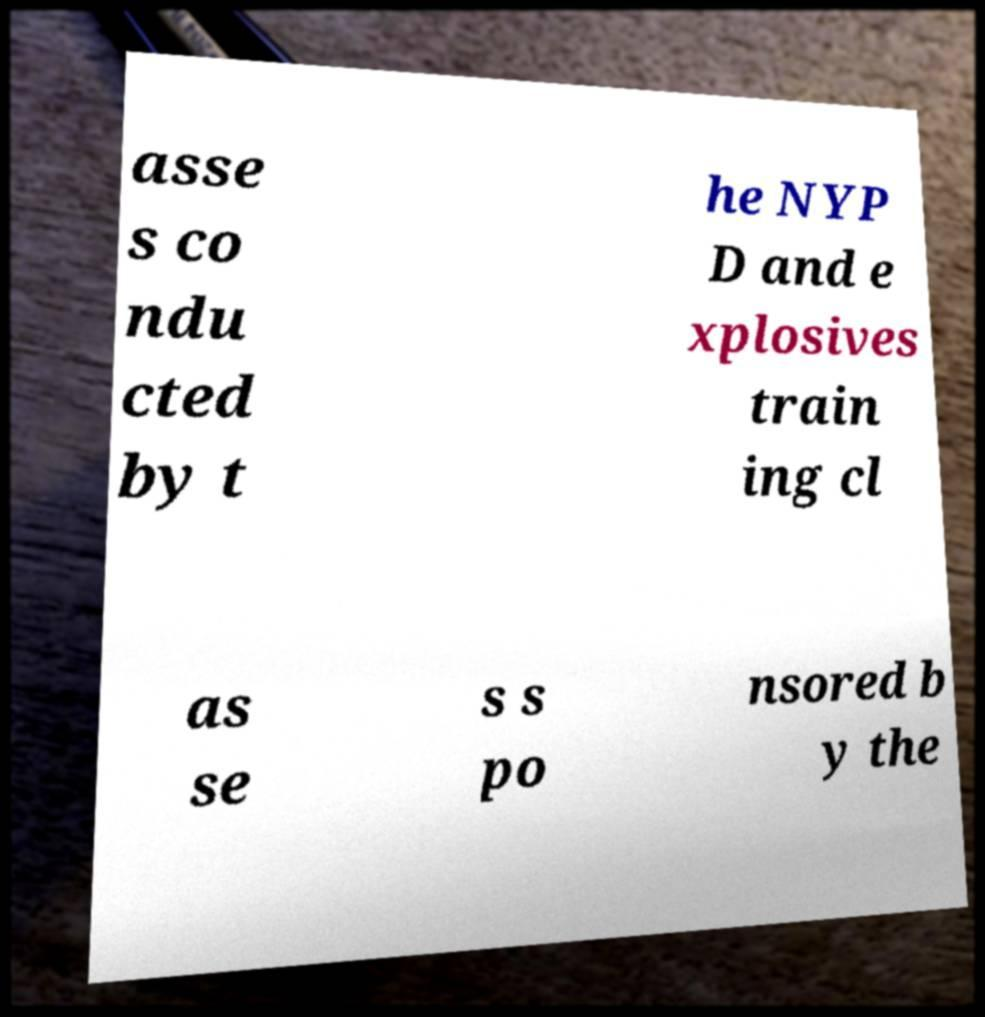There's text embedded in this image that I need extracted. Can you transcribe it verbatim? asse s co ndu cted by t he NYP D and e xplosives train ing cl as se s s po nsored b y the 